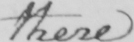What does this handwritten line say? there 